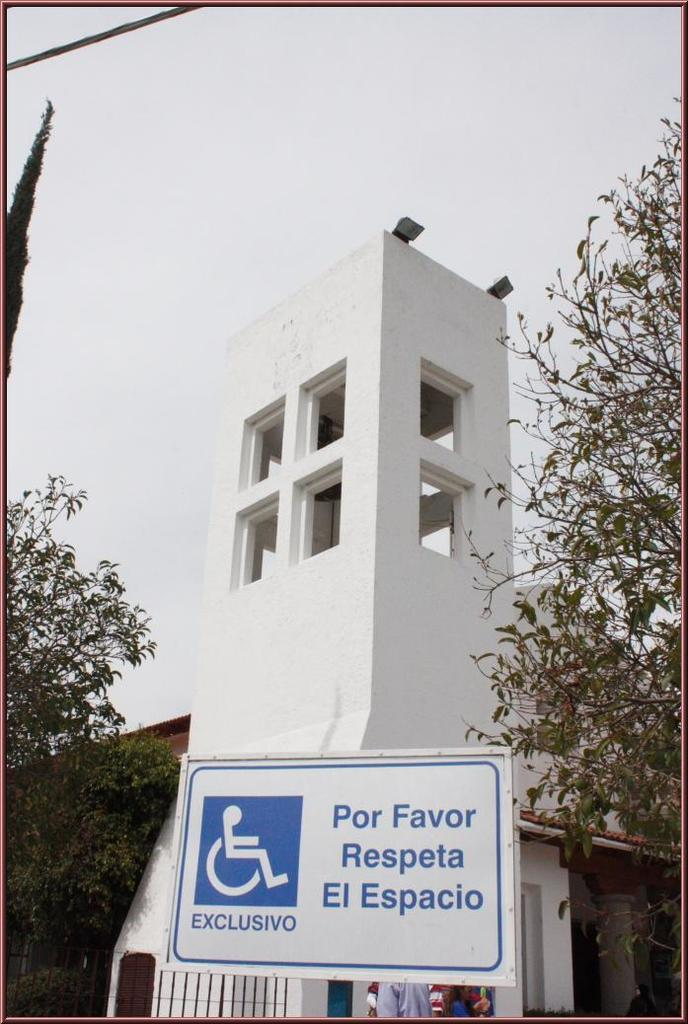What type of structure is present in the image? There is a building in the image. What other natural elements can be seen in the image? There are trees in the image. What additional feature is present in the image? There is a banner in the image. Are there any living beings visible in the image? Yes, there are people in the image. What can be seen in the background of the image? The sky is visible in the image. Can you tell me how many coils are present in the image? There are no coils present in the image. Is there any quicksand visible in the image? There is no quicksand present in the image. 